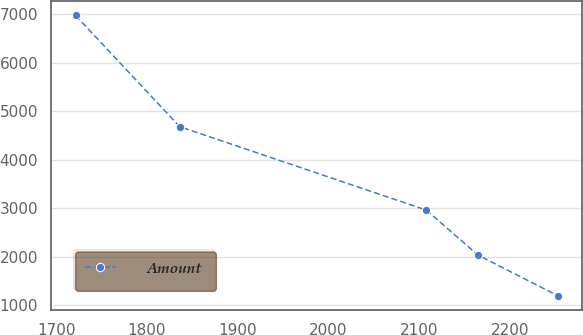Convert chart. <chart><loc_0><loc_0><loc_500><loc_500><line_chart><ecel><fcel>Amount<nl><fcel>1721.27<fcel>6980.69<nl><fcel>1835.97<fcel>4684.23<nl><fcel>2107.82<fcel>2959.93<nl><fcel>2164.42<fcel>2033.96<nl><fcel>2252.94<fcel>1189.25<nl></chart> 